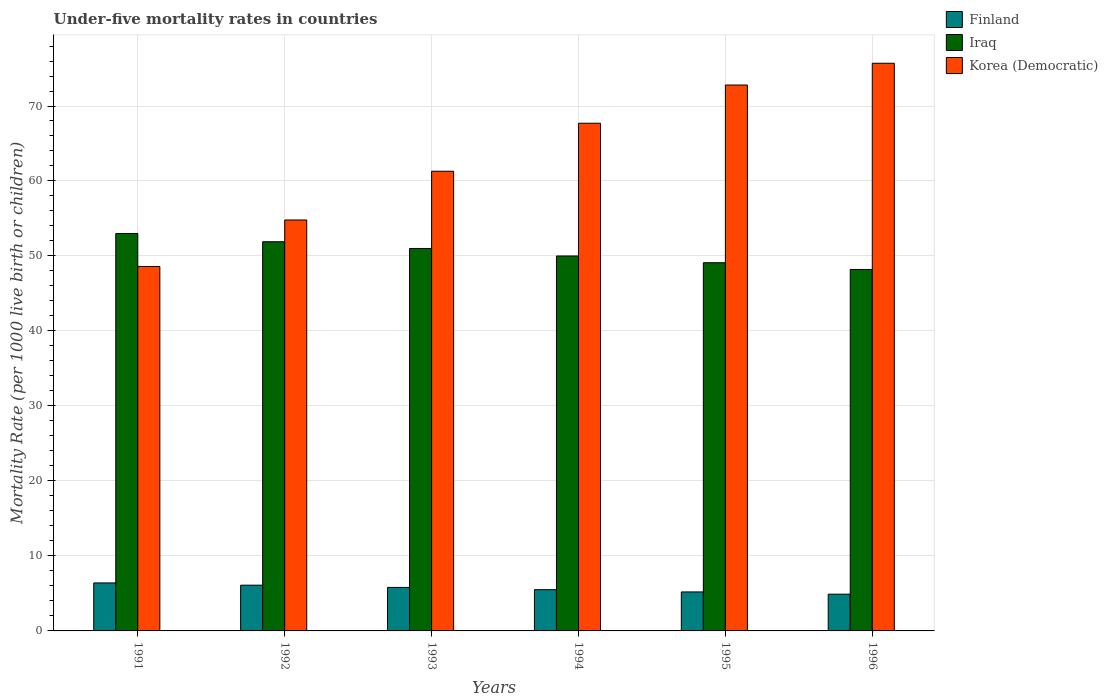How many different coloured bars are there?
Keep it short and to the point. 3. How many bars are there on the 2nd tick from the left?
Your answer should be compact. 3. How many bars are there on the 6th tick from the right?
Provide a succinct answer. 3. In how many cases, is the number of bars for a given year not equal to the number of legend labels?
Offer a terse response. 0. What is the under-five mortality rate in Iraq in 1995?
Offer a very short reply. 49.1. Across all years, what is the maximum under-five mortality rate in Korea (Democratic)?
Your answer should be very brief. 75.7. Across all years, what is the minimum under-five mortality rate in Korea (Democratic)?
Give a very brief answer. 48.6. What is the total under-five mortality rate in Iraq in the graph?
Keep it short and to the point. 303.2. What is the difference between the under-five mortality rate in Korea (Democratic) in 1991 and that in 1995?
Make the answer very short. -24.2. What is the difference between the under-five mortality rate in Korea (Democratic) in 1992 and the under-five mortality rate in Iraq in 1995?
Offer a very short reply. 5.7. What is the average under-five mortality rate in Iraq per year?
Offer a very short reply. 50.53. In the year 1995, what is the difference between the under-five mortality rate in Iraq and under-five mortality rate in Finland?
Keep it short and to the point. 43.9. In how many years, is the under-five mortality rate in Finland greater than 70?
Provide a short and direct response. 0. What is the ratio of the under-five mortality rate in Finland in 1994 to that in 1996?
Give a very brief answer. 1.12. Is the difference between the under-five mortality rate in Iraq in 1993 and 1996 greater than the difference between the under-five mortality rate in Finland in 1993 and 1996?
Offer a very short reply. Yes. What is the difference between the highest and the second highest under-five mortality rate in Iraq?
Offer a very short reply. 1.1. What is the difference between the highest and the lowest under-five mortality rate in Iraq?
Your answer should be very brief. 4.8. In how many years, is the under-five mortality rate in Finland greater than the average under-five mortality rate in Finland taken over all years?
Make the answer very short. 3. Is the sum of the under-five mortality rate in Iraq in 1992 and 1993 greater than the maximum under-five mortality rate in Korea (Democratic) across all years?
Your response must be concise. Yes. What does the 2nd bar from the left in 1995 represents?
Provide a short and direct response. Iraq. What does the 1st bar from the right in 1996 represents?
Offer a terse response. Korea (Democratic). How many bars are there?
Your answer should be very brief. 18. Are all the bars in the graph horizontal?
Your answer should be compact. No. How many years are there in the graph?
Your answer should be compact. 6. Does the graph contain any zero values?
Your answer should be very brief. No. What is the title of the graph?
Provide a short and direct response. Under-five mortality rates in countries. Does "Armenia" appear as one of the legend labels in the graph?
Offer a very short reply. No. What is the label or title of the X-axis?
Ensure brevity in your answer.  Years. What is the label or title of the Y-axis?
Offer a terse response. Mortality Rate (per 1000 live birth or children). What is the Mortality Rate (per 1000 live birth or children) of Iraq in 1991?
Your answer should be very brief. 53. What is the Mortality Rate (per 1000 live birth or children) of Korea (Democratic) in 1991?
Offer a terse response. 48.6. What is the Mortality Rate (per 1000 live birth or children) in Iraq in 1992?
Your answer should be compact. 51.9. What is the Mortality Rate (per 1000 live birth or children) of Korea (Democratic) in 1992?
Your answer should be compact. 54.8. What is the Mortality Rate (per 1000 live birth or children) in Korea (Democratic) in 1993?
Provide a succinct answer. 61.3. What is the Mortality Rate (per 1000 live birth or children) of Finland in 1994?
Offer a very short reply. 5.5. What is the Mortality Rate (per 1000 live birth or children) in Korea (Democratic) in 1994?
Make the answer very short. 67.7. What is the Mortality Rate (per 1000 live birth or children) of Finland in 1995?
Keep it short and to the point. 5.2. What is the Mortality Rate (per 1000 live birth or children) in Iraq in 1995?
Keep it short and to the point. 49.1. What is the Mortality Rate (per 1000 live birth or children) in Korea (Democratic) in 1995?
Provide a succinct answer. 72.8. What is the Mortality Rate (per 1000 live birth or children) in Finland in 1996?
Your answer should be very brief. 4.9. What is the Mortality Rate (per 1000 live birth or children) in Iraq in 1996?
Provide a succinct answer. 48.2. What is the Mortality Rate (per 1000 live birth or children) of Korea (Democratic) in 1996?
Make the answer very short. 75.7. Across all years, what is the maximum Mortality Rate (per 1000 live birth or children) of Finland?
Keep it short and to the point. 6.4. Across all years, what is the maximum Mortality Rate (per 1000 live birth or children) of Iraq?
Keep it short and to the point. 53. Across all years, what is the maximum Mortality Rate (per 1000 live birth or children) in Korea (Democratic)?
Your answer should be compact. 75.7. Across all years, what is the minimum Mortality Rate (per 1000 live birth or children) in Finland?
Provide a short and direct response. 4.9. Across all years, what is the minimum Mortality Rate (per 1000 live birth or children) of Iraq?
Offer a very short reply. 48.2. Across all years, what is the minimum Mortality Rate (per 1000 live birth or children) of Korea (Democratic)?
Provide a short and direct response. 48.6. What is the total Mortality Rate (per 1000 live birth or children) in Finland in the graph?
Provide a succinct answer. 33.9. What is the total Mortality Rate (per 1000 live birth or children) of Iraq in the graph?
Offer a very short reply. 303.2. What is the total Mortality Rate (per 1000 live birth or children) in Korea (Democratic) in the graph?
Your answer should be very brief. 380.9. What is the difference between the Mortality Rate (per 1000 live birth or children) in Finland in 1991 and that in 1992?
Your response must be concise. 0.3. What is the difference between the Mortality Rate (per 1000 live birth or children) in Iraq in 1991 and that in 1993?
Make the answer very short. 2. What is the difference between the Mortality Rate (per 1000 live birth or children) of Iraq in 1991 and that in 1994?
Offer a terse response. 3. What is the difference between the Mortality Rate (per 1000 live birth or children) in Korea (Democratic) in 1991 and that in 1994?
Make the answer very short. -19.1. What is the difference between the Mortality Rate (per 1000 live birth or children) of Korea (Democratic) in 1991 and that in 1995?
Give a very brief answer. -24.2. What is the difference between the Mortality Rate (per 1000 live birth or children) of Finland in 1991 and that in 1996?
Make the answer very short. 1.5. What is the difference between the Mortality Rate (per 1000 live birth or children) of Iraq in 1991 and that in 1996?
Your response must be concise. 4.8. What is the difference between the Mortality Rate (per 1000 live birth or children) of Korea (Democratic) in 1991 and that in 1996?
Make the answer very short. -27.1. What is the difference between the Mortality Rate (per 1000 live birth or children) in Korea (Democratic) in 1992 and that in 1993?
Provide a short and direct response. -6.5. What is the difference between the Mortality Rate (per 1000 live birth or children) in Finland in 1992 and that in 1994?
Offer a very short reply. 0.6. What is the difference between the Mortality Rate (per 1000 live birth or children) of Iraq in 1992 and that in 1994?
Provide a short and direct response. 1.9. What is the difference between the Mortality Rate (per 1000 live birth or children) of Finland in 1992 and that in 1995?
Your answer should be very brief. 0.9. What is the difference between the Mortality Rate (per 1000 live birth or children) in Iraq in 1992 and that in 1995?
Make the answer very short. 2.8. What is the difference between the Mortality Rate (per 1000 live birth or children) in Finland in 1992 and that in 1996?
Provide a succinct answer. 1.2. What is the difference between the Mortality Rate (per 1000 live birth or children) of Iraq in 1992 and that in 1996?
Provide a short and direct response. 3.7. What is the difference between the Mortality Rate (per 1000 live birth or children) of Korea (Democratic) in 1992 and that in 1996?
Your answer should be compact. -20.9. What is the difference between the Mortality Rate (per 1000 live birth or children) in Finland in 1993 and that in 1996?
Your answer should be very brief. 0.9. What is the difference between the Mortality Rate (per 1000 live birth or children) of Korea (Democratic) in 1993 and that in 1996?
Your response must be concise. -14.4. What is the difference between the Mortality Rate (per 1000 live birth or children) in Finland in 1994 and that in 1995?
Offer a very short reply. 0.3. What is the difference between the Mortality Rate (per 1000 live birth or children) of Iraq in 1994 and that in 1995?
Your response must be concise. 0.9. What is the difference between the Mortality Rate (per 1000 live birth or children) in Korea (Democratic) in 1994 and that in 1995?
Offer a terse response. -5.1. What is the difference between the Mortality Rate (per 1000 live birth or children) of Iraq in 1994 and that in 1996?
Your answer should be very brief. 1.8. What is the difference between the Mortality Rate (per 1000 live birth or children) in Korea (Democratic) in 1994 and that in 1996?
Provide a short and direct response. -8. What is the difference between the Mortality Rate (per 1000 live birth or children) in Korea (Democratic) in 1995 and that in 1996?
Keep it short and to the point. -2.9. What is the difference between the Mortality Rate (per 1000 live birth or children) in Finland in 1991 and the Mortality Rate (per 1000 live birth or children) in Iraq in 1992?
Offer a terse response. -45.5. What is the difference between the Mortality Rate (per 1000 live birth or children) of Finland in 1991 and the Mortality Rate (per 1000 live birth or children) of Korea (Democratic) in 1992?
Keep it short and to the point. -48.4. What is the difference between the Mortality Rate (per 1000 live birth or children) in Iraq in 1991 and the Mortality Rate (per 1000 live birth or children) in Korea (Democratic) in 1992?
Offer a very short reply. -1.8. What is the difference between the Mortality Rate (per 1000 live birth or children) of Finland in 1991 and the Mortality Rate (per 1000 live birth or children) of Iraq in 1993?
Your answer should be very brief. -44.6. What is the difference between the Mortality Rate (per 1000 live birth or children) in Finland in 1991 and the Mortality Rate (per 1000 live birth or children) in Korea (Democratic) in 1993?
Ensure brevity in your answer.  -54.9. What is the difference between the Mortality Rate (per 1000 live birth or children) of Finland in 1991 and the Mortality Rate (per 1000 live birth or children) of Iraq in 1994?
Your answer should be compact. -43.6. What is the difference between the Mortality Rate (per 1000 live birth or children) in Finland in 1991 and the Mortality Rate (per 1000 live birth or children) in Korea (Democratic) in 1994?
Make the answer very short. -61.3. What is the difference between the Mortality Rate (per 1000 live birth or children) in Iraq in 1991 and the Mortality Rate (per 1000 live birth or children) in Korea (Democratic) in 1994?
Your answer should be very brief. -14.7. What is the difference between the Mortality Rate (per 1000 live birth or children) in Finland in 1991 and the Mortality Rate (per 1000 live birth or children) in Iraq in 1995?
Keep it short and to the point. -42.7. What is the difference between the Mortality Rate (per 1000 live birth or children) in Finland in 1991 and the Mortality Rate (per 1000 live birth or children) in Korea (Democratic) in 1995?
Make the answer very short. -66.4. What is the difference between the Mortality Rate (per 1000 live birth or children) of Iraq in 1991 and the Mortality Rate (per 1000 live birth or children) of Korea (Democratic) in 1995?
Keep it short and to the point. -19.8. What is the difference between the Mortality Rate (per 1000 live birth or children) of Finland in 1991 and the Mortality Rate (per 1000 live birth or children) of Iraq in 1996?
Ensure brevity in your answer.  -41.8. What is the difference between the Mortality Rate (per 1000 live birth or children) of Finland in 1991 and the Mortality Rate (per 1000 live birth or children) of Korea (Democratic) in 1996?
Offer a terse response. -69.3. What is the difference between the Mortality Rate (per 1000 live birth or children) of Iraq in 1991 and the Mortality Rate (per 1000 live birth or children) of Korea (Democratic) in 1996?
Your answer should be very brief. -22.7. What is the difference between the Mortality Rate (per 1000 live birth or children) in Finland in 1992 and the Mortality Rate (per 1000 live birth or children) in Iraq in 1993?
Offer a terse response. -44.9. What is the difference between the Mortality Rate (per 1000 live birth or children) in Finland in 1992 and the Mortality Rate (per 1000 live birth or children) in Korea (Democratic) in 1993?
Your answer should be very brief. -55.2. What is the difference between the Mortality Rate (per 1000 live birth or children) in Finland in 1992 and the Mortality Rate (per 1000 live birth or children) in Iraq in 1994?
Offer a very short reply. -43.9. What is the difference between the Mortality Rate (per 1000 live birth or children) of Finland in 1992 and the Mortality Rate (per 1000 live birth or children) of Korea (Democratic) in 1994?
Your answer should be very brief. -61.6. What is the difference between the Mortality Rate (per 1000 live birth or children) in Iraq in 1992 and the Mortality Rate (per 1000 live birth or children) in Korea (Democratic) in 1994?
Your answer should be very brief. -15.8. What is the difference between the Mortality Rate (per 1000 live birth or children) in Finland in 1992 and the Mortality Rate (per 1000 live birth or children) in Iraq in 1995?
Your answer should be very brief. -43. What is the difference between the Mortality Rate (per 1000 live birth or children) of Finland in 1992 and the Mortality Rate (per 1000 live birth or children) of Korea (Democratic) in 1995?
Give a very brief answer. -66.7. What is the difference between the Mortality Rate (per 1000 live birth or children) of Iraq in 1992 and the Mortality Rate (per 1000 live birth or children) of Korea (Democratic) in 1995?
Keep it short and to the point. -20.9. What is the difference between the Mortality Rate (per 1000 live birth or children) in Finland in 1992 and the Mortality Rate (per 1000 live birth or children) in Iraq in 1996?
Offer a terse response. -42.1. What is the difference between the Mortality Rate (per 1000 live birth or children) of Finland in 1992 and the Mortality Rate (per 1000 live birth or children) of Korea (Democratic) in 1996?
Provide a succinct answer. -69.6. What is the difference between the Mortality Rate (per 1000 live birth or children) of Iraq in 1992 and the Mortality Rate (per 1000 live birth or children) of Korea (Democratic) in 1996?
Your response must be concise. -23.8. What is the difference between the Mortality Rate (per 1000 live birth or children) of Finland in 1993 and the Mortality Rate (per 1000 live birth or children) of Iraq in 1994?
Keep it short and to the point. -44.2. What is the difference between the Mortality Rate (per 1000 live birth or children) in Finland in 1993 and the Mortality Rate (per 1000 live birth or children) in Korea (Democratic) in 1994?
Keep it short and to the point. -61.9. What is the difference between the Mortality Rate (per 1000 live birth or children) in Iraq in 1993 and the Mortality Rate (per 1000 live birth or children) in Korea (Democratic) in 1994?
Give a very brief answer. -16.7. What is the difference between the Mortality Rate (per 1000 live birth or children) of Finland in 1993 and the Mortality Rate (per 1000 live birth or children) of Iraq in 1995?
Make the answer very short. -43.3. What is the difference between the Mortality Rate (per 1000 live birth or children) in Finland in 1993 and the Mortality Rate (per 1000 live birth or children) in Korea (Democratic) in 1995?
Keep it short and to the point. -67. What is the difference between the Mortality Rate (per 1000 live birth or children) in Iraq in 1993 and the Mortality Rate (per 1000 live birth or children) in Korea (Democratic) in 1995?
Ensure brevity in your answer.  -21.8. What is the difference between the Mortality Rate (per 1000 live birth or children) in Finland in 1993 and the Mortality Rate (per 1000 live birth or children) in Iraq in 1996?
Offer a terse response. -42.4. What is the difference between the Mortality Rate (per 1000 live birth or children) of Finland in 1993 and the Mortality Rate (per 1000 live birth or children) of Korea (Democratic) in 1996?
Ensure brevity in your answer.  -69.9. What is the difference between the Mortality Rate (per 1000 live birth or children) in Iraq in 1993 and the Mortality Rate (per 1000 live birth or children) in Korea (Democratic) in 1996?
Offer a terse response. -24.7. What is the difference between the Mortality Rate (per 1000 live birth or children) of Finland in 1994 and the Mortality Rate (per 1000 live birth or children) of Iraq in 1995?
Give a very brief answer. -43.6. What is the difference between the Mortality Rate (per 1000 live birth or children) in Finland in 1994 and the Mortality Rate (per 1000 live birth or children) in Korea (Democratic) in 1995?
Your response must be concise. -67.3. What is the difference between the Mortality Rate (per 1000 live birth or children) of Iraq in 1994 and the Mortality Rate (per 1000 live birth or children) of Korea (Democratic) in 1995?
Make the answer very short. -22.8. What is the difference between the Mortality Rate (per 1000 live birth or children) of Finland in 1994 and the Mortality Rate (per 1000 live birth or children) of Iraq in 1996?
Your answer should be compact. -42.7. What is the difference between the Mortality Rate (per 1000 live birth or children) of Finland in 1994 and the Mortality Rate (per 1000 live birth or children) of Korea (Democratic) in 1996?
Make the answer very short. -70.2. What is the difference between the Mortality Rate (per 1000 live birth or children) in Iraq in 1994 and the Mortality Rate (per 1000 live birth or children) in Korea (Democratic) in 1996?
Ensure brevity in your answer.  -25.7. What is the difference between the Mortality Rate (per 1000 live birth or children) of Finland in 1995 and the Mortality Rate (per 1000 live birth or children) of Iraq in 1996?
Your response must be concise. -43. What is the difference between the Mortality Rate (per 1000 live birth or children) in Finland in 1995 and the Mortality Rate (per 1000 live birth or children) in Korea (Democratic) in 1996?
Keep it short and to the point. -70.5. What is the difference between the Mortality Rate (per 1000 live birth or children) in Iraq in 1995 and the Mortality Rate (per 1000 live birth or children) in Korea (Democratic) in 1996?
Your answer should be compact. -26.6. What is the average Mortality Rate (per 1000 live birth or children) in Finland per year?
Your answer should be compact. 5.65. What is the average Mortality Rate (per 1000 live birth or children) in Iraq per year?
Keep it short and to the point. 50.53. What is the average Mortality Rate (per 1000 live birth or children) in Korea (Democratic) per year?
Offer a very short reply. 63.48. In the year 1991, what is the difference between the Mortality Rate (per 1000 live birth or children) of Finland and Mortality Rate (per 1000 live birth or children) of Iraq?
Ensure brevity in your answer.  -46.6. In the year 1991, what is the difference between the Mortality Rate (per 1000 live birth or children) of Finland and Mortality Rate (per 1000 live birth or children) of Korea (Democratic)?
Ensure brevity in your answer.  -42.2. In the year 1992, what is the difference between the Mortality Rate (per 1000 live birth or children) in Finland and Mortality Rate (per 1000 live birth or children) in Iraq?
Offer a very short reply. -45.8. In the year 1992, what is the difference between the Mortality Rate (per 1000 live birth or children) of Finland and Mortality Rate (per 1000 live birth or children) of Korea (Democratic)?
Provide a short and direct response. -48.7. In the year 1992, what is the difference between the Mortality Rate (per 1000 live birth or children) of Iraq and Mortality Rate (per 1000 live birth or children) of Korea (Democratic)?
Provide a succinct answer. -2.9. In the year 1993, what is the difference between the Mortality Rate (per 1000 live birth or children) in Finland and Mortality Rate (per 1000 live birth or children) in Iraq?
Provide a succinct answer. -45.2. In the year 1993, what is the difference between the Mortality Rate (per 1000 live birth or children) of Finland and Mortality Rate (per 1000 live birth or children) of Korea (Democratic)?
Your response must be concise. -55.5. In the year 1994, what is the difference between the Mortality Rate (per 1000 live birth or children) in Finland and Mortality Rate (per 1000 live birth or children) in Iraq?
Your answer should be compact. -44.5. In the year 1994, what is the difference between the Mortality Rate (per 1000 live birth or children) of Finland and Mortality Rate (per 1000 live birth or children) of Korea (Democratic)?
Make the answer very short. -62.2. In the year 1994, what is the difference between the Mortality Rate (per 1000 live birth or children) of Iraq and Mortality Rate (per 1000 live birth or children) of Korea (Democratic)?
Keep it short and to the point. -17.7. In the year 1995, what is the difference between the Mortality Rate (per 1000 live birth or children) of Finland and Mortality Rate (per 1000 live birth or children) of Iraq?
Provide a short and direct response. -43.9. In the year 1995, what is the difference between the Mortality Rate (per 1000 live birth or children) of Finland and Mortality Rate (per 1000 live birth or children) of Korea (Democratic)?
Provide a short and direct response. -67.6. In the year 1995, what is the difference between the Mortality Rate (per 1000 live birth or children) of Iraq and Mortality Rate (per 1000 live birth or children) of Korea (Democratic)?
Provide a short and direct response. -23.7. In the year 1996, what is the difference between the Mortality Rate (per 1000 live birth or children) in Finland and Mortality Rate (per 1000 live birth or children) in Iraq?
Ensure brevity in your answer.  -43.3. In the year 1996, what is the difference between the Mortality Rate (per 1000 live birth or children) in Finland and Mortality Rate (per 1000 live birth or children) in Korea (Democratic)?
Your response must be concise. -70.8. In the year 1996, what is the difference between the Mortality Rate (per 1000 live birth or children) in Iraq and Mortality Rate (per 1000 live birth or children) in Korea (Democratic)?
Provide a succinct answer. -27.5. What is the ratio of the Mortality Rate (per 1000 live birth or children) in Finland in 1991 to that in 1992?
Keep it short and to the point. 1.05. What is the ratio of the Mortality Rate (per 1000 live birth or children) in Iraq in 1991 to that in 1992?
Your answer should be very brief. 1.02. What is the ratio of the Mortality Rate (per 1000 live birth or children) of Korea (Democratic) in 1991 to that in 1992?
Your answer should be very brief. 0.89. What is the ratio of the Mortality Rate (per 1000 live birth or children) of Finland in 1991 to that in 1993?
Your response must be concise. 1.1. What is the ratio of the Mortality Rate (per 1000 live birth or children) of Iraq in 1991 to that in 1993?
Provide a short and direct response. 1.04. What is the ratio of the Mortality Rate (per 1000 live birth or children) of Korea (Democratic) in 1991 to that in 1993?
Make the answer very short. 0.79. What is the ratio of the Mortality Rate (per 1000 live birth or children) in Finland in 1991 to that in 1994?
Keep it short and to the point. 1.16. What is the ratio of the Mortality Rate (per 1000 live birth or children) in Iraq in 1991 to that in 1994?
Ensure brevity in your answer.  1.06. What is the ratio of the Mortality Rate (per 1000 live birth or children) of Korea (Democratic) in 1991 to that in 1994?
Your response must be concise. 0.72. What is the ratio of the Mortality Rate (per 1000 live birth or children) in Finland in 1991 to that in 1995?
Offer a terse response. 1.23. What is the ratio of the Mortality Rate (per 1000 live birth or children) of Iraq in 1991 to that in 1995?
Provide a short and direct response. 1.08. What is the ratio of the Mortality Rate (per 1000 live birth or children) in Korea (Democratic) in 1991 to that in 1995?
Ensure brevity in your answer.  0.67. What is the ratio of the Mortality Rate (per 1000 live birth or children) of Finland in 1991 to that in 1996?
Ensure brevity in your answer.  1.31. What is the ratio of the Mortality Rate (per 1000 live birth or children) of Iraq in 1991 to that in 1996?
Ensure brevity in your answer.  1.1. What is the ratio of the Mortality Rate (per 1000 live birth or children) in Korea (Democratic) in 1991 to that in 1996?
Provide a short and direct response. 0.64. What is the ratio of the Mortality Rate (per 1000 live birth or children) in Finland in 1992 to that in 1993?
Offer a very short reply. 1.05. What is the ratio of the Mortality Rate (per 1000 live birth or children) in Iraq in 1992 to that in 1993?
Provide a short and direct response. 1.02. What is the ratio of the Mortality Rate (per 1000 live birth or children) in Korea (Democratic) in 1992 to that in 1993?
Provide a succinct answer. 0.89. What is the ratio of the Mortality Rate (per 1000 live birth or children) in Finland in 1992 to that in 1994?
Keep it short and to the point. 1.11. What is the ratio of the Mortality Rate (per 1000 live birth or children) of Iraq in 1992 to that in 1994?
Your answer should be very brief. 1.04. What is the ratio of the Mortality Rate (per 1000 live birth or children) in Korea (Democratic) in 1992 to that in 1994?
Make the answer very short. 0.81. What is the ratio of the Mortality Rate (per 1000 live birth or children) in Finland in 1992 to that in 1995?
Your answer should be compact. 1.17. What is the ratio of the Mortality Rate (per 1000 live birth or children) in Iraq in 1992 to that in 1995?
Offer a very short reply. 1.06. What is the ratio of the Mortality Rate (per 1000 live birth or children) in Korea (Democratic) in 1992 to that in 1995?
Give a very brief answer. 0.75. What is the ratio of the Mortality Rate (per 1000 live birth or children) of Finland in 1992 to that in 1996?
Your response must be concise. 1.24. What is the ratio of the Mortality Rate (per 1000 live birth or children) in Iraq in 1992 to that in 1996?
Provide a short and direct response. 1.08. What is the ratio of the Mortality Rate (per 1000 live birth or children) in Korea (Democratic) in 1992 to that in 1996?
Your answer should be compact. 0.72. What is the ratio of the Mortality Rate (per 1000 live birth or children) of Finland in 1993 to that in 1994?
Make the answer very short. 1.05. What is the ratio of the Mortality Rate (per 1000 live birth or children) of Iraq in 1993 to that in 1994?
Provide a succinct answer. 1.02. What is the ratio of the Mortality Rate (per 1000 live birth or children) in Korea (Democratic) in 1993 to that in 1994?
Make the answer very short. 0.91. What is the ratio of the Mortality Rate (per 1000 live birth or children) in Finland in 1993 to that in 1995?
Your answer should be compact. 1.12. What is the ratio of the Mortality Rate (per 1000 live birth or children) in Iraq in 1993 to that in 1995?
Keep it short and to the point. 1.04. What is the ratio of the Mortality Rate (per 1000 live birth or children) in Korea (Democratic) in 1993 to that in 1995?
Offer a terse response. 0.84. What is the ratio of the Mortality Rate (per 1000 live birth or children) in Finland in 1993 to that in 1996?
Make the answer very short. 1.18. What is the ratio of the Mortality Rate (per 1000 live birth or children) in Iraq in 1993 to that in 1996?
Provide a short and direct response. 1.06. What is the ratio of the Mortality Rate (per 1000 live birth or children) of Korea (Democratic) in 1993 to that in 1996?
Offer a very short reply. 0.81. What is the ratio of the Mortality Rate (per 1000 live birth or children) in Finland in 1994 to that in 1995?
Keep it short and to the point. 1.06. What is the ratio of the Mortality Rate (per 1000 live birth or children) in Iraq in 1994 to that in 1995?
Offer a very short reply. 1.02. What is the ratio of the Mortality Rate (per 1000 live birth or children) in Korea (Democratic) in 1994 to that in 1995?
Your answer should be compact. 0.93. What is the ratio of the Mortality Rate (per 1000 live birth or children) in Finland in 1994 to that in 1996?
Your answer should be compact. 1.12. What is the ratio of the Mortality Rate (per 1000 live birth or children) in Iraq in 1994 to that in 1996?
Offer a very short reply. 1.04. What is the ratio of the Mortality Rate (per 1000 live birth or children) in Korea (Democratic) in 1994 to that in 1996?
Give a very brief answer. 0.89. What is the ratio of the Mortality Rate (per 1000 live birth or children) of Finland in 1995 to that in 1996?
Offer a very short reply. 1.06. What is the ratio of the Mortality Rate (per 1000 live birth or children) in Iraq in 1995 to that in 1996?
Provide a succinct answer. 1.02. What is the ratio of the Mortality Rate (per 1000 live birth or children) of Korea (Democratic) in 1995 to that in 1996?
Offer a terse response. 0.96. What is the difference between the highest and the lowest Mortality Rate (per 1000 live birth or children) in Iraq?
Ensure brevity in your answer.  4.8. What is the difference between the highest and the lowest Mortality Rate (per 1000 live birth or children) in Korea (Democratic)?
Provide a short and direct response. 27.1. 